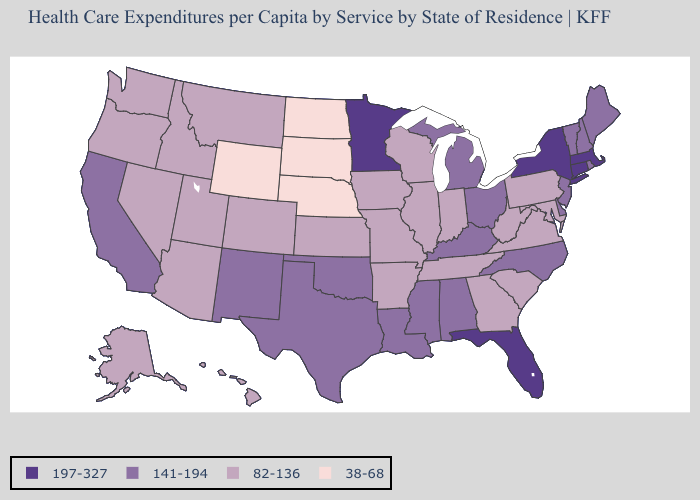Which states have the highest value in the USA?
Give a very brief answer. Connecticut, Florida, Massachusetts, Minnesota, New York. What is the lowest value in states that border West Virginia?
Short answer required. 82-136. What is the value of Maryland?
Write a very short answer. 82-136. What is the value of Kansas?
Be succinct. 82-136. What is the value of Michigan?
Concise answer only. 141-194. What is the value of South Carolina?
Be succinct. 82-136. Name the states that have a value in the range 38-68?
Write a very short answer. Nebraska, North Dakota, South Dakota, Wyoming. Does Florida have the same value as Massachusetts?
Keep it brief. Yes. Name the states that have a value in the range 141-194?
Answer briefly. Alabama, California, Delaware, Kentucky, Louisiana, Maine, Michigan, Mississippi, New Hampshire, New Jersey, New Mexico, North Carolina, Ohio, Oklahoma, Rhode Island, Texas, Vermont. Among the states that border California , which have the lowest value?
Concise answer only. Arizona, Nevada, Oregon. Name the states that have a value in the range 38-68?
Answer briefly. Nebraska, North Dakota, South Dakota, Wyoming. Name the states that have a value in the range 38-68?
Answer briefly. Nebraska, North Dakota, South Dakota, Wyoming. What is the value of Oregon?
Write a very short answer. 82-136. What is the value of California?
Short answer required. 141-194. 